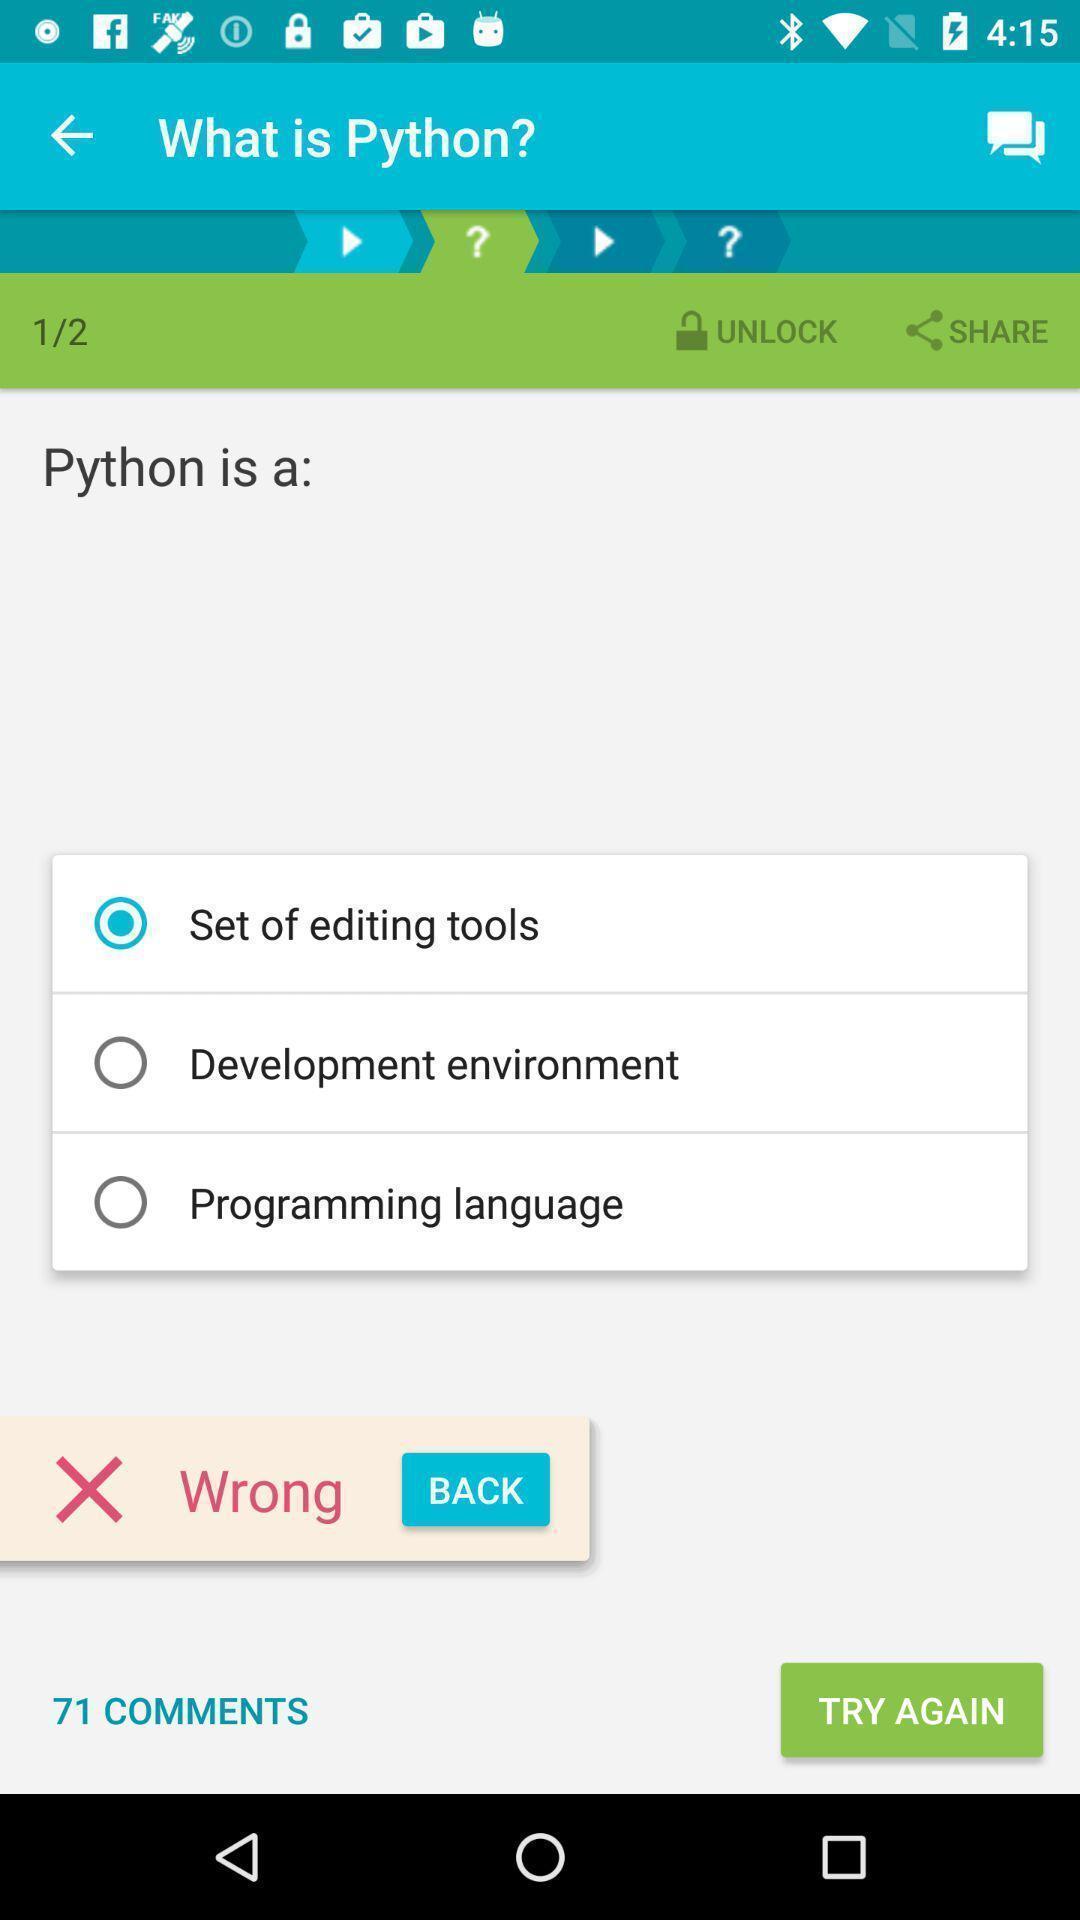What details can you identify in this image? Question and answer page of learning environment app. 